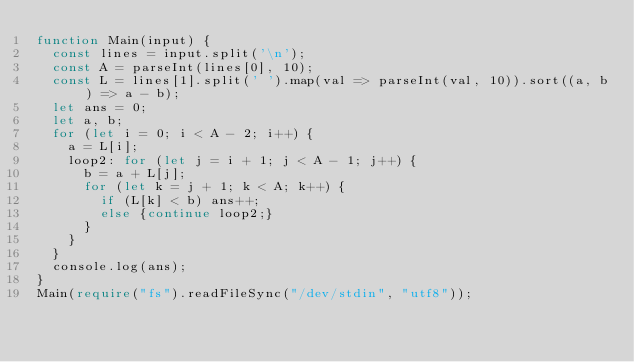<code> <loc_0><loc_0><loc_500><loc_500><_TypeScript_>function Main(input) {
  const lines = input.split('\n');
  const A = parseInt(lines[0], 10);
  const L = lines[1].split(' ').map(val => parseInt(val, 10)).sort((a, b) => a - b);
  let ans = 0;
  let a, b;
  for (let i = 0; i < A - 2; i++) {
    a = L[i];
    loop2: for (let j = i + 1; j < A - 1; j++) {
      b = a + L[j];
      for (let k = j + 1; k < A; k++) {
        if (L[k] < b) ans++;
        else {continue loop2;}
      }
    }
  }
  console.log(ans);
}
Main(require("fs").readFileSync("/dev/stdin", "utf8"));</code> 